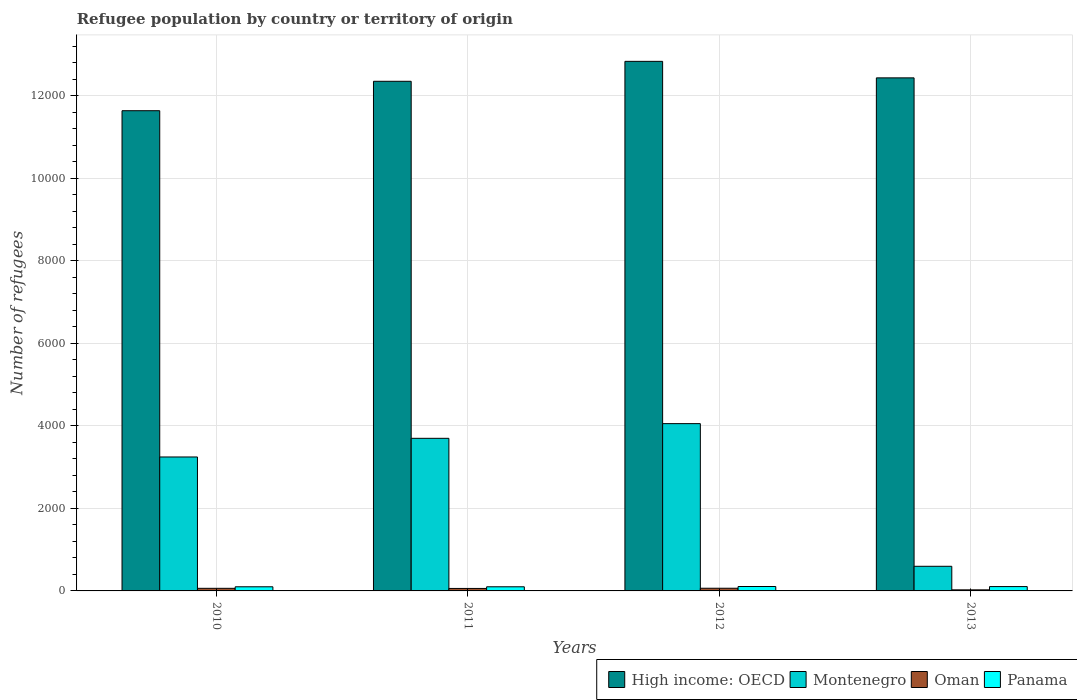Are the number of bars on each tick of the X-axis equal?
Ensure brevity in your answer.  Yes. How many bars are there on the 2nd tick from the right?
Give a very brief answer. 4. What is the number of refugees in Panama in 2012?
Your answer should be compact. 107. Across all years, what is the maximum number of refugees in Panama?
Provide a succinct answer. 107. Across all years, what is the minimum number of refugees in Montenegro?
Offer a terse response. 597. In which year was the number of refugees in Panama maximum?
Your answer should be very brief. 2012. What is the total number of refugees in Montenegro in the graph?
Offer a terse response. 1.16e+04. What is the difference between the number of refugees in Montenegro in 2011 and that in 2012?
Make the answer very short. -356. What is the difference between the number of refugees in Panama in 2011 and the number of refugees in Oman in 2013?
Provide a succinct answer. 74. What is the average number of refugees in Oman per year?
Provide a short and direct response. 53.5. In how many years, is the number of refugees in Oman greater than 6400?
Offer a very short reply. 0. What is the ratio of the number of refugees in High income: OECD in 2011 to that in 2012?
Make the answer very short. 0.96. Is the number of refugees in Oman in 2010 less than that in 2013?
Your answer should be very brief. No. Is the difference between the number of refugees in Panama in 2010 and 2011 greater than the difference between the number of refugees in Oman in 2010 and 2011?
Your answer should be very brief. No. What is the difference between the highest and the second highest number of refugees in Oman?
Your answer should be compact. 2. What is the difference between the highest and the lowest number of refugees in High income: OECD?
Your answer should be compact. 1196. Is it the case that in every year, the sum of the number of refugees in Oman and number of refugees in High income: OECD is greater than the sum of number of refugees in Montenegro and number of refugees in Panama?
Give a very brief answer. Yes. What does the 2nd bar from the left in 2011 represents?
Your answer should be very brief. Montenegro. What does the 3rd bar from the right in 2013 represents?
Your answer should be compact. Montenegro. Are all the bars in the graph horizontal?
Provide a short and direct response. No. What is the difference between two consecutive major ticks on the Y-axis?
Provide a short and direct response. 2000. Are the values on the major ticks of Y-axis written in scientific E-notation?
Provide a succinct answer. No. Does the graph contain grids?
Give a very brief answer. Yes. How are the legend labels stacked?
Keep it short and to the point. Horizontal. What is the title of the graph?
Make the answer very short. Refugee population by country or territory of origin. What is the label or title of the Y-axis?
Ensure brevity in your answer.  Number of refugees. What is the Number of refugees in High income: OECD in 2010?
Ensure brevity in your answer.  1.16e+04. What is the Number of refugees of Montenegro in 2010?
Make the answer very short. 3246. What is the Number of refugees in High income: OECD in 2011?
Keep it short and to the point. 1.24e+04. What is the Number of refugees of Montenegro in 2011?
Your response must be concise. 3698. What is the Number of refugees in Oman in 2011?
Keep it short and to the point. 60. What is the Number of refugees in Panama in 2011?
Offer a very short reply. 100. What is the Number of refugees in High income: OECD in 2012?
Your answer should be compact. 1.28e+04. What is the Number of refugees in Montenegro in 2012?
Offer a terse response. 4054. What is the Number of refugees in Panama in 2012?
Your answer should be compact. 107. What is the Number of refugees in High income: OECD in 2013?
Keep it short and to the point. 1.24e+04. What is the Number of refugees of Montenegro in 2013?
Keep it short and to the point. 597. What is the Number of refugees in Panama in 2013?
Offer a terse response. 105. Across all years, what is the maximum Number of refugees in High income: OECD?
Keep it short and to the point. 1.28e+04. Across all years, what is the maximum Number of refugees in Montenegro?
Make the answer very short. 4054. Across all years, what is the maximum Number of refugees of Panama?
Keep it short and to the point. 107. Across all years, what is the minimum Number of refugees in High income: OECD?
Keep it short and to the point. 1.16e+04. Across all years, what is the minimum Number of refugees in Montenegro?
Offer a terse response. 597. Across all years, what is the minimum Number of refugees of Oman?
Provide a short and direct response. 26. What is the total Number of refugees of High income: OECD in the graph?
Your answer should be compact. 4.93e+04. What is the total Number of refugees in Montenegro in the graph?
Offer a terse response. 1.16e+04. What is the total Number of refugees of Oman in the graph?
Keep it short and to the point. 214. What is the total Number of refugees of Panama in the graph?
Keep it short and to the point. 412. What is the difference between the Number of refugees in High income: OECD in 2010 and that in 2011?
Give a very brief answer. -713. What is the difference between the Number of refugees of Montenegro in 2010 and that in 2011?
Give a very brief answer. -452. What is the difference between the Number of refugees in Panama in 2010 and that in 2011?
Offer a terse response. 0. What is the difference between the Number of refugees in High income: OECD in 2010 and that in 2012?
Provide a succinct answer. -1196. What is the difference between the Number of refugees in Montenegro in 2010 and that in 2012?
Provide a short and direct response. -808. What is the difference between the Number of refugees in High income: OECD in 2010 and that in 2013?
Provide a short and direct response. -796. What is the difference between the Number of refugees of Montenegro in 2010 and that in 2013?
Your answer should be compact. 2649. What is the difference between the Number of refugees in Oman in 2010 and that in 2013?
Offer a very short reply. 37. What is the difference between the Number of refugees of High income: OECD in 2011 and that in 2012?
Offer a very short reply. -483. What is the difference between the Number of refugees in Montenegro in 2011 and that in 2012?
Your answer should be compact. -356. What is the difference between the Number of refugees in Oman in 2011 and that in 2012?
Your response must be concise. -5. What is the difference between the Number of refugees in Panama in 2011 and that in 2012?
Provide a succinct answer. -7. What is the difference between the Number of refugees in High income: OECD in 2011 and that in 2013?
Provide a succinct answer. -83. What is the difference between the Number of refugees of Montenegro in 2011 and that in 2013?
Provide a short and direct response. 3101. What is the difference between the Number of refugees of High income: OECD in 2012 and that in 2013?
Your response must be concise. 400. What is the difference between the Number of refugees of Montenegro in 2012 and that in 2013?
Keep it short and to the point. 3457. What is the difference between the Number of refugees of Oman in 2012 and that in 2013?
Make the answer very short. 39. What is the difference between the Number of refugees of High income: OECD in 2010 and the Number of refugees of Montenegro in 2011?
Provide a succinct answer. 7939. What is the difference between the Number of refugees in High income: OECD in 2010 and the Number of refugees in Oman in 2011?
Provide a succinct answer. 1.16e+04. What is the difference between the Number of refugees in High income: OECD in 2010 and the Number of refugees in Panama in 2011?
Give a very brief answer. 1.15e+04. What is the difference between the Number of refugees in Montenegro in 2010 and the Number of refugees in Oman in 2011?
Provide a succinct answer. 3186. What is the difference between the Number of refugees in Montenegro in 2010 and the Number of refugees in Panama in 2011?
Ensure brevity in your answer.  3146. What is the difference between the Number of refugees in Oman in 2010 and the Number of refugees in Panama in 2011?
Your answer should be compact. -37. What is the difference between the Number of refugees in High income: OECD in 2010 and the Number of refugees in Montenegro in 2012?
Ensure brevity in your answer.  7583. What is the difference between the Number of refugees of High income: OECD in 2010 and the Number of refugees of Oman in 2012?
Offer a very short reply. 1.16e+04. What is the difference between the Number of refugees in High income: OECD in 2010 and the Number of refugees in Panama in 2012?
Provide a succinct answer. 1.15e+04. What is the difference between the Number of refugees of Montenegro in 2010 and the Number of refugees of Oman in 2012?
Keep it short and to the point. 3181. What is the difference between the Number of refugees in Montenegro in 2010 and the Number of refugees in Panama in 2012?
Offer a very short reply. 3139. What is the difference between the Number of refugees of Oman in 2010 and the Number of refugees of Panama in 2012?
Your response must be concise. -44. What is the difference between the Number of refugees of High income: OECD in 2010 and the Number of refugees of Montenegro in 2013?
Offer a very short reply. 1.10e+04. What is the difference between the Number of refugees of High income: OECD in 2010 and the Number of refugees of Oman in 2013?
Offer a terse response. 1.16e+04. What is the difference between the Number of refugees of High income: OECD in 2010 and the Number of refugees of Panama in 2013?
Make the answer very short. 1.15e+04. What is the difference between the Number of refugees in Montenegro in 2010 and the Number of refugees in Oman in 2013?
Make the answer very short. 3220. What is the difference between the Number of refugees in Montenegro in 2010 and the Number of refugees in Panama in 2013?
Provide a short and direct response. 3141. What is the difference between the Number of refugees of Oman in 2010 and the Number of refugees of Panama in 2013?
Your response must be concise. -42. What is the difference between the Number of refugees in High income: OECD in 2011 and the Number of refugees in Montenegro in 2012?
Give a very brief answer. 8296. What is the difference between the Number of refugees in High income: OECD in 2011 and the Number of refugees in Oman in 2012?
Ensure brevity in your answer.  1.23e+04. What is the difference between the Number of refugees in High income: OECD in 2011 and the Number of refugees in Panama in 2012?
Offer a terse response. 1.22e+04. What is the difference between the Number of refugees in Montenegro in 2011 and the Number of refugees in Oman in 2012?
Your answer should be compact. 3633. What is the difference between the Number of refugees in Montenegro in 2011 and the Number of refugees in Panama in 2012?
Your answer should be very brief. 3591. What is the difference between the Number of refugees in Oman in 2011 and the Number of refugees in Panama in 2012?
Offer a terse response. -47. What is the difference between the Number of refugees in High income: OECD in 2011 and the Number of refugees in Montenegro in 2013?
Provide a succinct answer. 1.18e+04. What is the difference between the Number of refugees of High income: OECD in 2011 and the Number of refugees of Oman in 2013?
Your answer should be compact. 1.23e+04. What is the difference between the Number of refugees in High income: OECD in 2011 and the Number of refugees in Panama in 2013?
Offer a very short reply. 1.22e+04. What is the difference between the Number of refugees of Montenegro in 2011 and the Number of refugees of Oman in 2013?
Offer a terse response. 3672. What is the difference between the Number of refugees in Montenegro in 2011 and the Number of refugees in Panama in 2013?
Offer a terse response. 3593. What is the difference between the Number of refugees in Oman in 2011 and the Number of refugees in Panama in 2013?
Offer a very short reply. -45. What is the difference between the Number of refugees of High income: OECD in 2012 and the Number of refugees of Montenegro in 2013?
Provide a short and direct response. 1.22e+04. What is the difference between the Number of refugees in High income: OECD in 2012 and the Number of refugees in Oman in 2013?
Provide a succinct answer. 1.28e+04. What is the difference between the Number of refugees of High income: OECD in 2012 and the Number of refugees of Panama in 2013?
Your answer should be compact. 1.27e+04. What is the difference between the Number of refugees of Montenegro in 2012 and the Number of refugees of Oman in 2013?
Offer a very short reply. 4028. What is the difference between the Number of refugees of Montenegro in 2012 and the Number of refugees of Panama in 2013?
Your response must be concise. 3949. What is the difference between the Number of refugees in Oman in 2012 and the Number of refugees in Panama in 2013?
Offer a terse response. -40. What is the average Number of refugees in High income: OECD per year?
Give a very brief answer. 1.23e+04. What is the average Number of refugees of Montenegro per year?
Your answer should be compact. 2898.75. What is the average Number of refugees of Oman per year?
Give a very brief answer. 53.5. What is the average Number of refugees of Panama per year?
Provide a succinct answer. 103. In the year 2010, what is the difference between the Number of refugees in High income: OECD and Number of refugees in Montenegro?
Make the answer very short. 8391. In the year 2010, what is the difference between the Number of refugees of High income: OECD and Number of refugees of Oman?
Give a very brief answer. 1.16e+04. In the year 2010, what is the difference between the Number of refugees of High income: OECD and Number of refugees of Panama?
Your answer should be very brief. 1.15e+04. In the year 2010, what is the difference between the Number of refugees of Montenegro and Number of refugees of Oman?
Keep it short and to the point. 3183. In the year 2010, what is the difference between the Number of refugees in Montenegro and Number of refugees in Panama?
Offer a terse response. 3146. In the year 2010, what is the difference between the Number of refugees of Oman and Number of refugees of Panama?
Provide a short and direct response. -37. In the year 2011, what is the difference between the Number of refugees of High income: OECD and Number of refugees of Montenegro?
Provide a short and direct response. 8652. In the year 2011, what is the difference between the Number of refugees of High income: OECD and Number of refugees of Oman?
Your answer should be compact. 1.23e+04. In the year 2011, what is the difference between the Number of refugees of High income: OECD and Number of refugees of Panama?
Give a very brief answer. 1.22e+04. In the year 2011, what is the difference between the Number of refugees of Montenegro and Number of refugees of Oman?
Ensure brevity in your answer.  3638. In the year 2011, what is the difference between the Number of refugees of Montenegro and Number of refugees of Panama?
Provide a succinct answer. 3598. In the year 2012, what is the difference between the Number of refugees of High income: OECD and Number of refugees of Montenegro?
Give a very brief answer. 8779. In the year 2012, what is the difference between the Number of refugees in High income: OECD and Number of refugees in Oman?
Make the answer very short. 1.28e+04. In the year 2012, what is the difference between the Number of refugees of High income: OECD and Number of refugees of Panama?
Make the answer very short. 1.27e+04. In the year 2012, what is the difference between the Number of refugees of Montenegro and Number of refugees of Oman?
Your answer should be compact. 3989. In the year 2012, what is the difference between the Number of refugees in Montenegro and Number of refugees in Panama?
Provide a short and direct response. 3947. In the year 2012, what is the difference between the Number of refugees in Oman and Number of refugees in Panama?
Keep it short and to the point. -42. In the year 2013, what is the difference between the Number of refugees in High income: OECD and Number of refugees in Montenegro?
Make the answer very short. 1.18e+04. In the year 2013, what is the difference between the Number of refugees of High income: OECD and Number of refugees of Oman?
Provide a succinct answer. 1.24e+04. In the year 2013, what is the difference between the Number of refugees of High income: OECD and Number of refugees of Panama?
Provide a short and direct response. 1.23e+04. In the year 2013, what is the difference between the Number of refugees in Montenegro and Number of refugees in Oman?
Your answer should be compact. 571. In the year 2013, what is the difference between the Number of refugees of Montenegro and Number of refugees of Panama?
Your answer should be very brief. 492. In the year 2013, what is the difference between the Number of refugees of Oman and Number of refugees of Panama?
Give a very brief answer. -79. What is the ratio of the Number of refugees of High income: OECD in 2010 to that in 2011?
Offer a very short reply. 0.94. What is the ratio of the Number of refugees in Montenegro in 2010 to that in 2011?
Make the answer very short. 0.88. What is the ratio of the Number of refugees of Oman in 2010 to that in 2011?
Your answer should be very brief. 1.05. What is the ratio of the Number of refugees in Panama in 2010 to that in 2011?
Keep it short and to the point. 1. What is the ratio of the Number of refugees of High income: OECD in 2010 to that in 2012?
Keep it short and to the point. 0.91. What is the ratio of the Number of refugees of Montenegro in 2010 to that in 2012?
Offer a terse response. 0.8. What is the ratio of the Number of refugees of Oman in 2010 to that in 2012?
Keep it short and to the point. 0.97. What is the ratio of the Number of refugees in Panama in 2010 to that in 2012?
Your answer should be compact. 0.93. What is the ratio of the Number of refugees in High income: OECD in 2010 to that in 2013?
Your response must be concise. 0.94. What is the ratio of the Number of refugees in Montenegro in 2010 to that in 2013?
Your answer should be very brief. 5.44. What is the ratio of the Number of refugees of Oman in 2010 to that in 2013?
Your response must be concise. 2.42. What is the ratio of the Number of refugees in High income: OECD in 2011 to that in 2012?
Offer a terse response. 0.96. What is the ratio of the Number of refugees in Montenegro in 2011 to that in 2012?
Provide a succinct answer. 0.91. What is the ratio of the Number of refugees in Oman in 2011 to that in 2012?
Provide a succinct answer. 0.92. What is the ratio of the Number of refugees of Panama in 2011 to that in 2012?
Offer a very short reply. 0.93. What is the ratio of the Number of refugees in Montenegro in 2011 to that in 2013?
Give a very brief answer. 6.19. What is the ratio of the Number of refugees in Oman in 2011 to that in 2013?
Keep it short and to the point. 2.31. What is the ratio of the Number of refugees of High income: OECD in 2012 to that in 2013?
Your response must be concise. 1.03. What is the ratio of the Number of refugees in Montenegro in 2012 to that in 2013?
Provide a short and direct response. 6.79. What is the ratio of the Number of refugees of Panama in 2012 to that in 2013?
Provide a succinct answer. 1.02. What is the difference between the highest and the second highest Number of refugees of Montenegro?
Offer a very short reply. 356. What is the difference between the highest and the second highest Number of refugees of Panama?
Your answer should be very brief. 2. What is the difference between the highest and the lowest Number of refugees in High income: OECD?
Provide a succinct answer. 1196. What is the difference between the highest and the lowest Number of refugees in Montenegro?
Ensure brevity in your answer.  3457. 